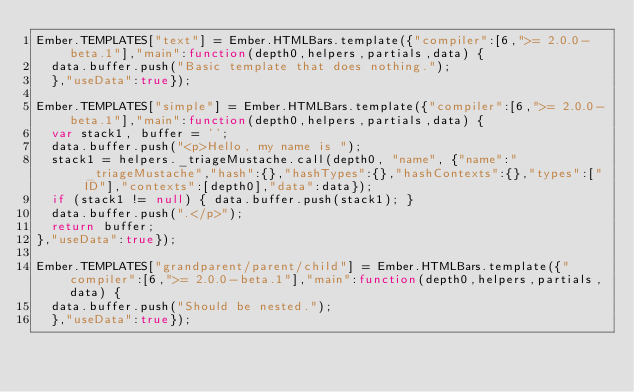Convert code to text. <code><loc_0><loc_0><loc_500><loc_500><_JavaScript_>Ember.TEMPLATES["text"] = Ember.HTMLBars.template({"compiler":[6,">= 2.0.0-beta.1"],"main":function(depth0,helpers,partials,data) {
  data.buffer.push("Basic template that does nothing.");
  },"useData":true});

Ember.TEMPLATES["simple"] = Ember.HTMLBars.template({"compiler":[6,">= 2.0.0-beta.1"],"main":function(depth0,helpers,partials,data) {
  var stack1, buffer = '';
  data.buffer.push("<p>Hello, my name is ");
  stack1 = helpers._triageMustache.call(depth0, "name", {"name":"_triageMustache","hash":{},"hashTypes":{},"hashContexts":{},"types":["ID"],"contexts":[depth0],"data":data});
  if (stack1 != null) { data.buffer.push(stack1); }
  data.buffer.push(".</p>");
  return buffer;
},"useData":true});

Ember.TEMPLATES["grandparent/parent/child"] = Ember.HTMLBars.template({"compiler":[6,">= 2.0.0-beta.1"],"main":function(depth0,helpers,partials,data) {
  data.buffer.push("Should be nested.");
  },"useData":true});</code> 